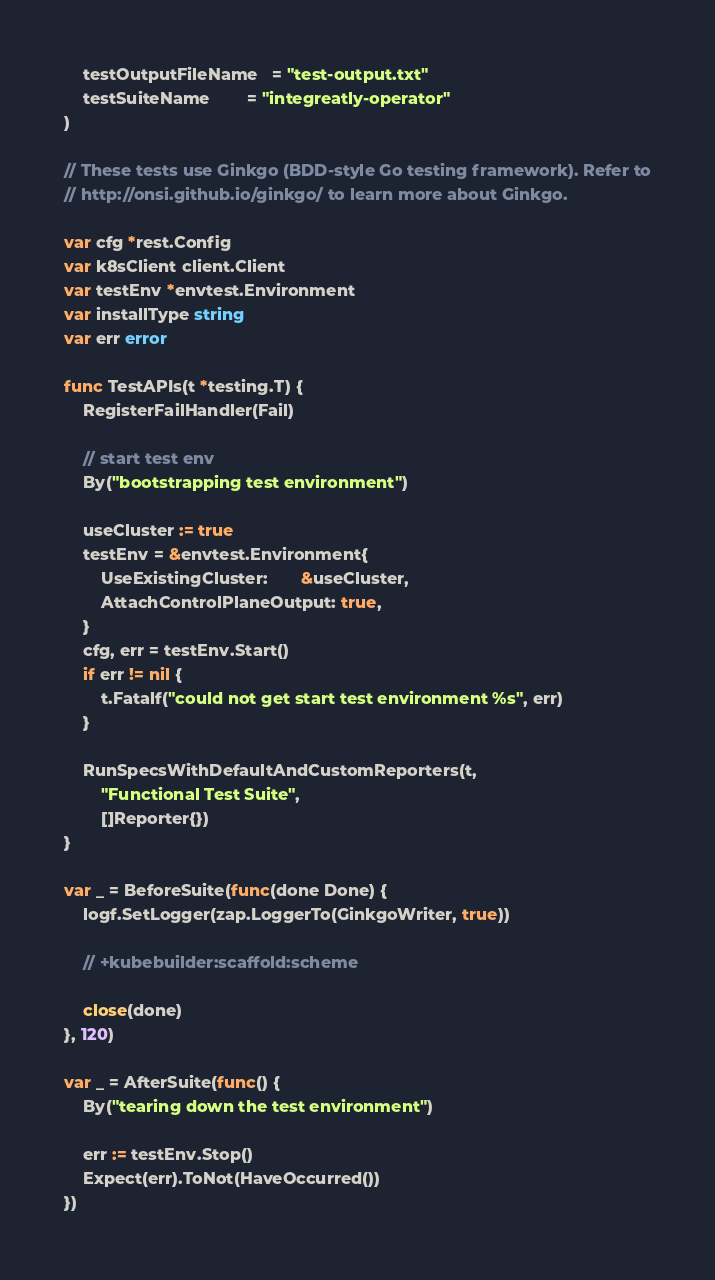Convert code to text. <code><loc_0><loc_0><loc_500><loc_500><_Go_>	testOutputFileName   = "test-output.txt"
	testSuiteName        = "integreatly-operator"
)

// These tests use Ginkgo (BDD-style Go testing framework). Refer to
// http://onsi.github.io/ginkgo/ to learn more about Ginkgo.

var cfg *rest.Config
var k8sClient client.Client
var testEnv *envtest.Environment
var installType string
var err error

func TestAPIs(t *testing.T) {
	RegisterFailHandler(Fail)

	// start test env
	By("bootstrapping test environment")

	useCluster := true
	testEnv = &envtest.Environment{
		UseExistingCluster:       &useCluster,
		AttachControlPlaneOutput: true,
	}
	cfg, err = testEnv.Start()
	if err != nil {
		t.Fatalf("could not get start test environment %s", err)
	}

	RunSpecsWithDefaultAndCustomReporters(t,
		"Functional Test Suite",
		[]Reporter{})
}

var _ = BeforeSuite(func(done Done) {
	logf.SetLogger(zap.LoggerTo(GinkgoWriter, true))

	// +kubebuilder:scaffold:scheme

	close(done)
}, 120)

var _ = AfterSuite(func() {
	By("tearing down the test environment")

	err := testEnv.Stop()
	Expect(err).ToNot(HaveOccurred())
})
</code> 